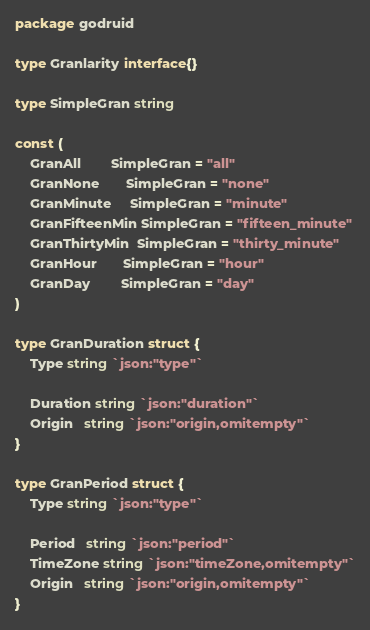Convert code to text. <code><loc_0><loc_0><loc_500><loc_500><_Go_>package godruid

type Granlarity interface{}

type SimpleGran string

const (
	GranAll        SimpleGran = "all"
	GranNone       SimpleGran = "none"
	GranMinute     SimpleGran = "minute"
	GranFifteenMin SimpleGran = "fifteen_minute"
	GranThirtyMin  SimpleGran = "thirty_minute"
	GranHour       SimpleGran = "hour"
	GranDay        SimpleGran = "day"
)

type GranDuration struct {
	Type string `json:"type"`

	Duration string `json:"duration"`
	Origin   string `json:"origin,omitempty"`
}

type GranPeriod struct {
	Type string `json:"type"`

	Period   string `json:"period"`
	TimeZone string `json:"timeZone,omitempty"`
	Origin   string `json:"origin,omitempty"`
}
</code> 